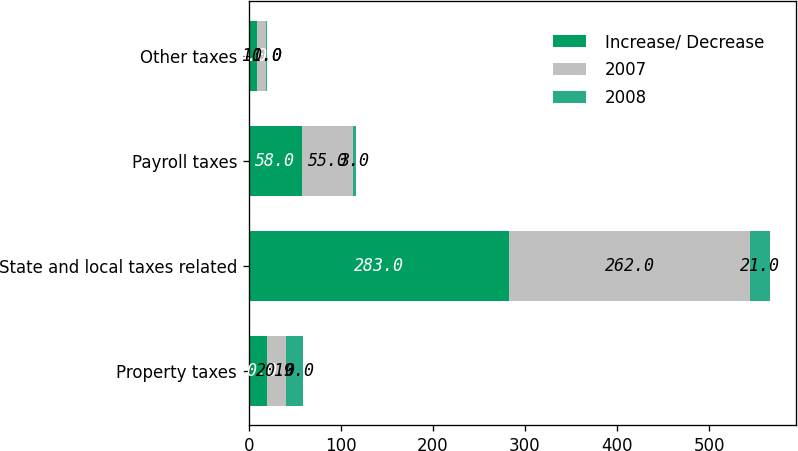Convert chart. <chart><loc_0><loc_0><loc_500><loc_500><stacked_bar_chart><ecel><fcel>Property taxes<fcel>State and local taxes related<fcel>Payroll taxes<fcel>Other taxes<nl><fcel>Increase/ Decrease<fcel>20<fcel>283<fcel>58<fcel>9<nl><fcel>2007<fcel>20<fcel>262<fcel>55<fcel>10<nl><fcel>2008<fcel>19<fcel>21<fcel>3<fcel>1<nl></chart> 